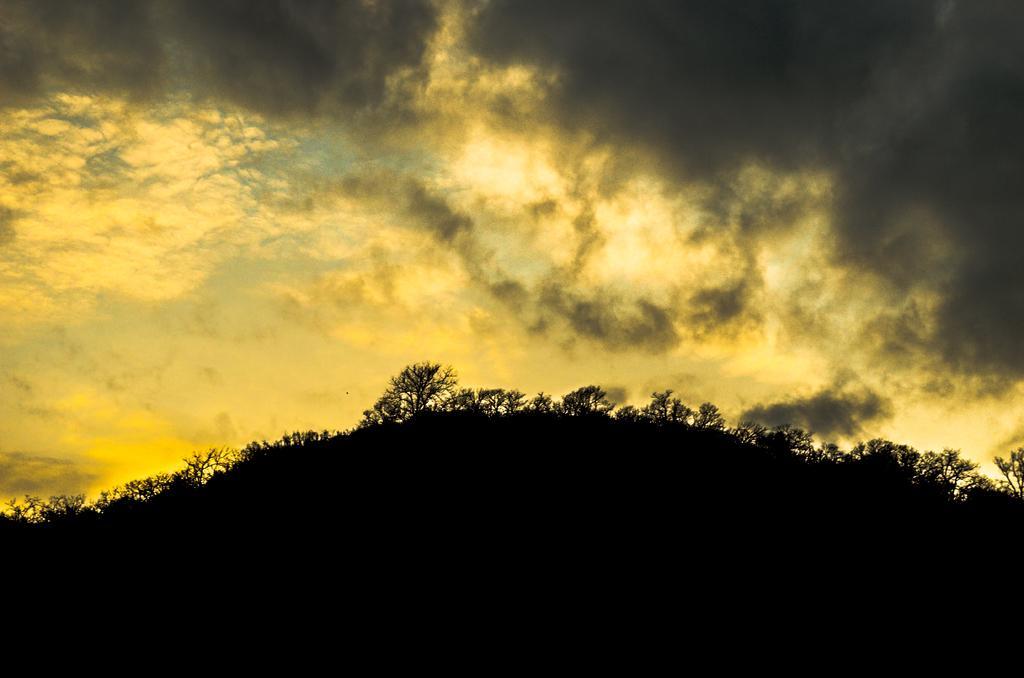Can you describe this image briefly? In this image we can see a mountain on which there are some trees and top of the image there is cloudy sky and the sky is in yellow and black color. 